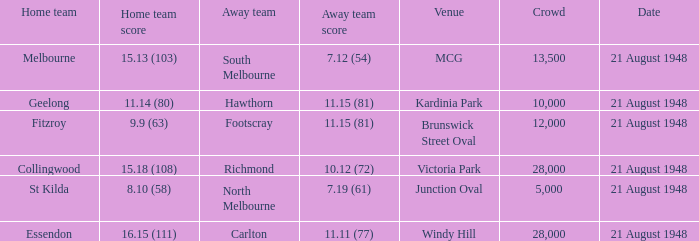15 (81), what is the location of the game? Brunswick Street Oval. 